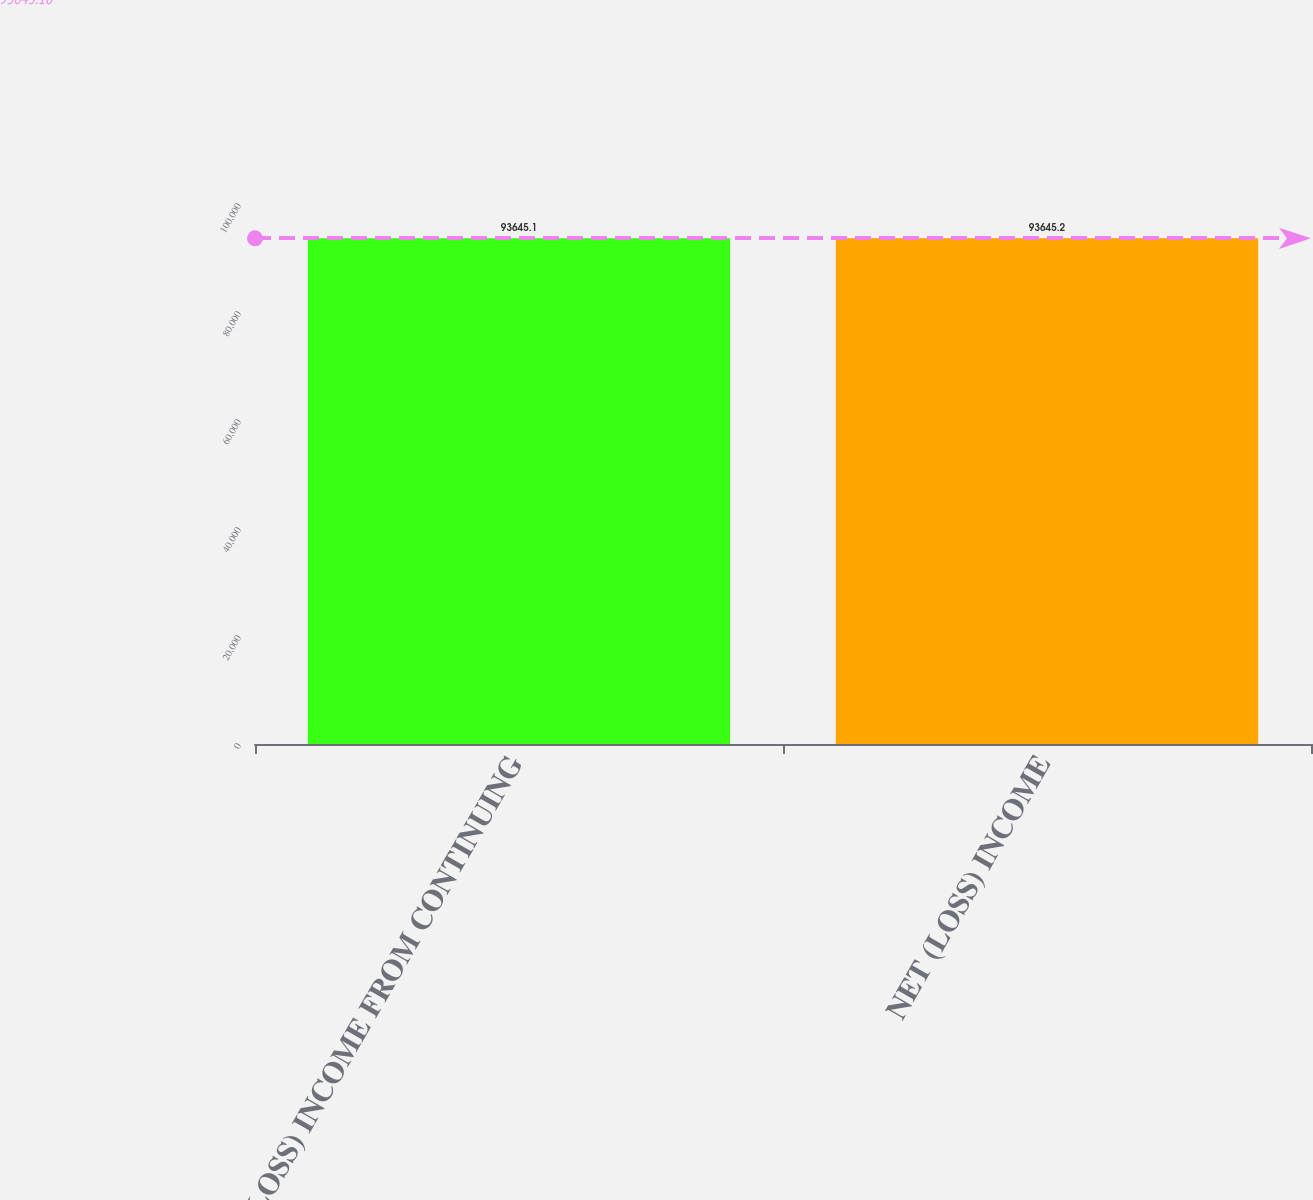Convert chart. <chart><loc_0><loc_0><loc_500><loc_500><bar_chart><fcel>(LOSS) INCOME FROM CONTINUING<fcel>NET (LOSS) INCOME<nl><fcel>93645.1<fcel>93645.2<nl></chart> 